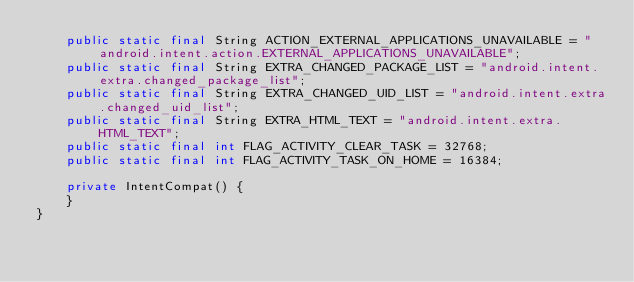<code> <loc_0><loc_0><loc_500><loc_500><_Java_>    public static final String ACTION_EXTERNAL_APPLICATIONS_UNAVAILABLE = "android.intent.action.EXTERNAL_APPLICATIONS_UNAVAILABLE";
    public static final String EXTRA_CHANGED_PACKAGE_LIST = "android.intent.extra.changed_package_list";
    public static final String EXTRA_CHANGED_UID_LIST = "android.intent.extra.changed_uid_list";
    public static final String EXTRA_HTML_TEXT = "android.intent.extra.HTML_TEXT";
    public static final int FLAG_ACTIVITY_CLEAR_TASK = 32768;
    public static final int FLAG_ACTIVITY_TASK_ON_HOME = 16384;

    private IntentCompat() {
    }
}
</code> 